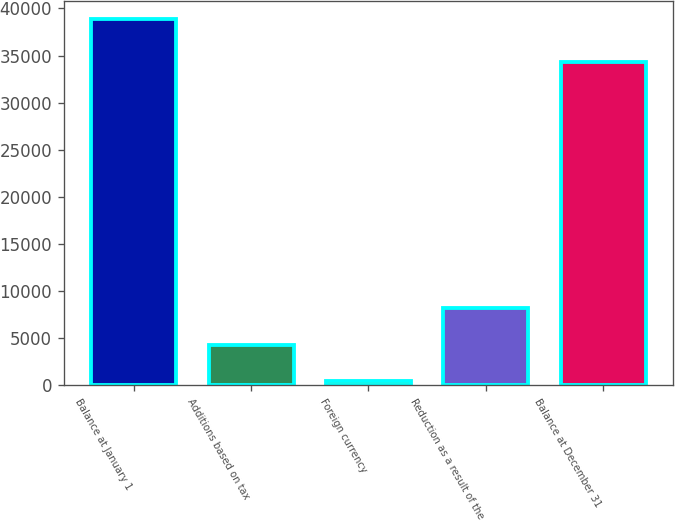<chart> <loc_0><loc_0><loc_500><loc_500><bar_chart><fcel>Balance at January 1<fcel>Additions based on tax<fcel>Foreign currency<fcel>Reduction as a result of the<fcel>Balance at December 31<nl><fcel>38886<fcel>4283.7<fcel>439<fcel>8128.4<fcel>34337<nl></chart> 